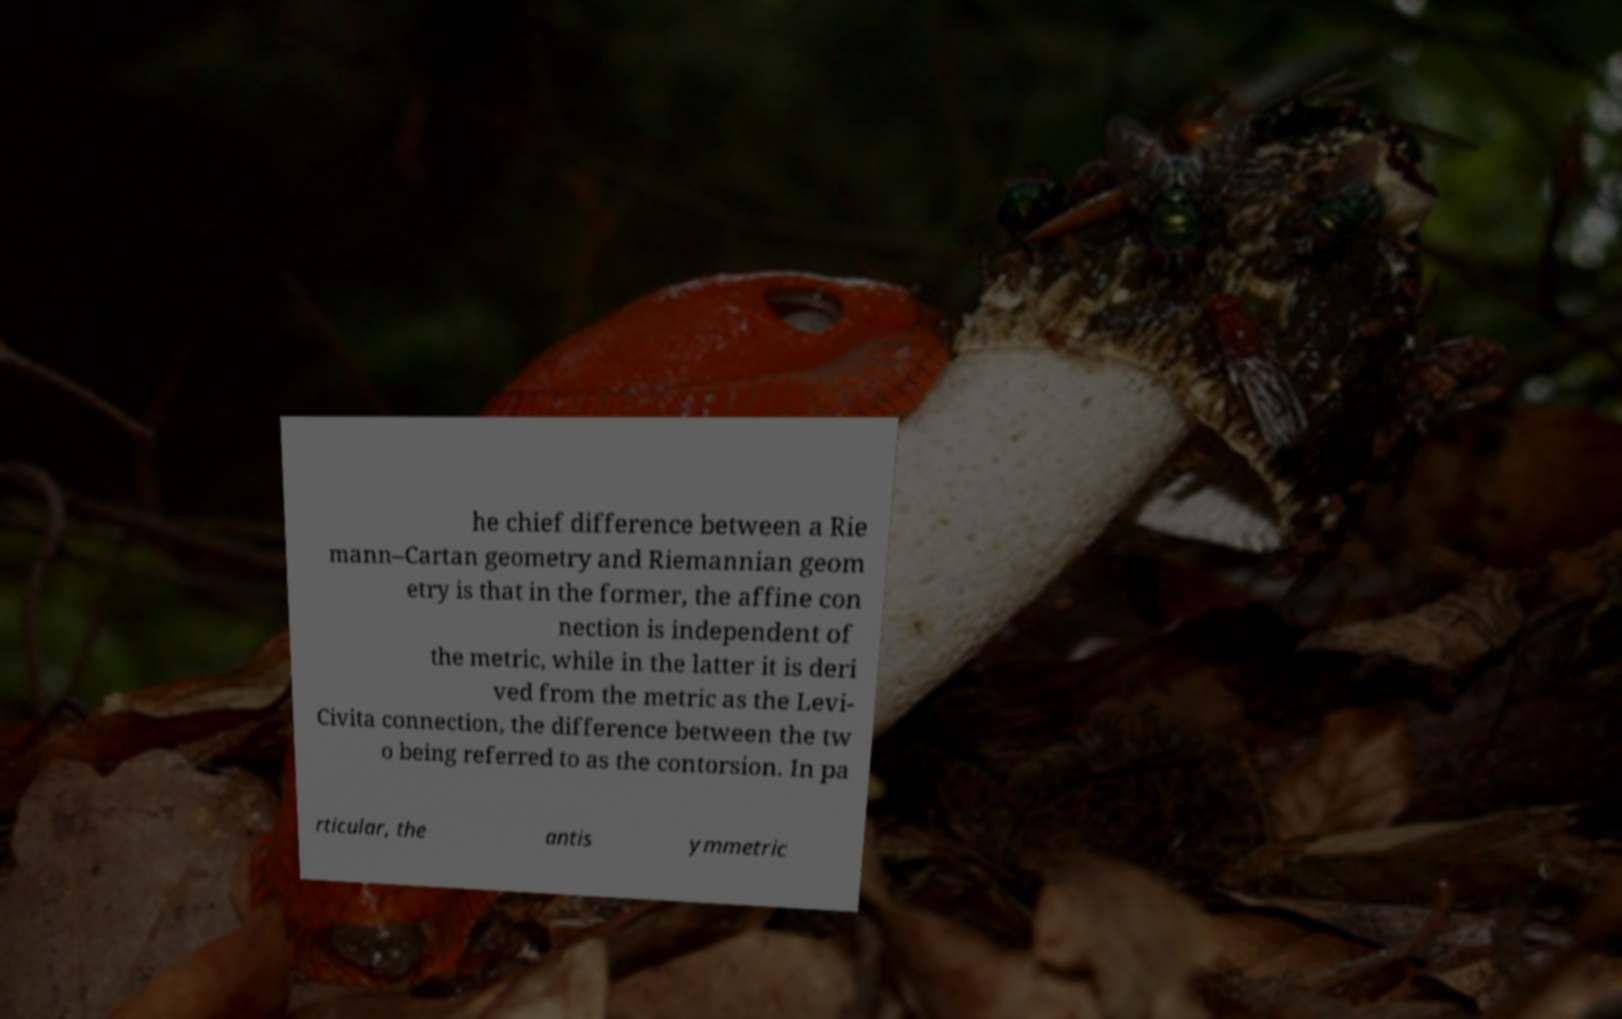I need the written content from this picture converted into text. Can you do that? he chief difference between a Rie mann–Cartan geometry and Riemannian geom etry is that in the former, the affine con nection is independent of the metric, while in the latter it is deri ved from the metric as the Levi- Civita connection, the difference between the tw o being referred to as the contorsion. In pa rticular, the antis ymmetric 